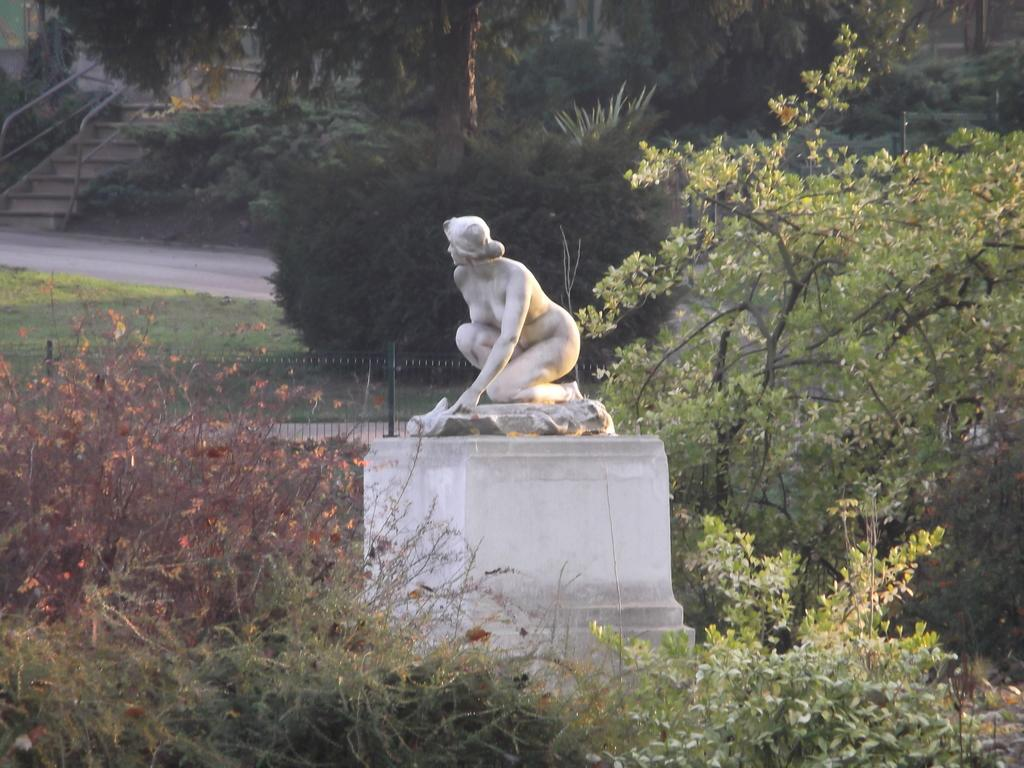What is the main subject of the image? There is a white color statue in the image. What type of natural elements can be seen in the image? There are trees in the image. What is visible in the background of the image? The background of the image contains fencing. Where are the stairs located in the image? The stairs are at the top left of the image. What feature is present on the stairs? The stairs have a railing. What type of leg is visible on the statue in the image? There is no leg visible on the statue in the image, as it is a statue and does not have human-like body parts. 